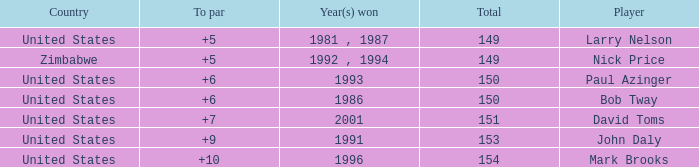Which player won in 1993? Paul Azinger. 